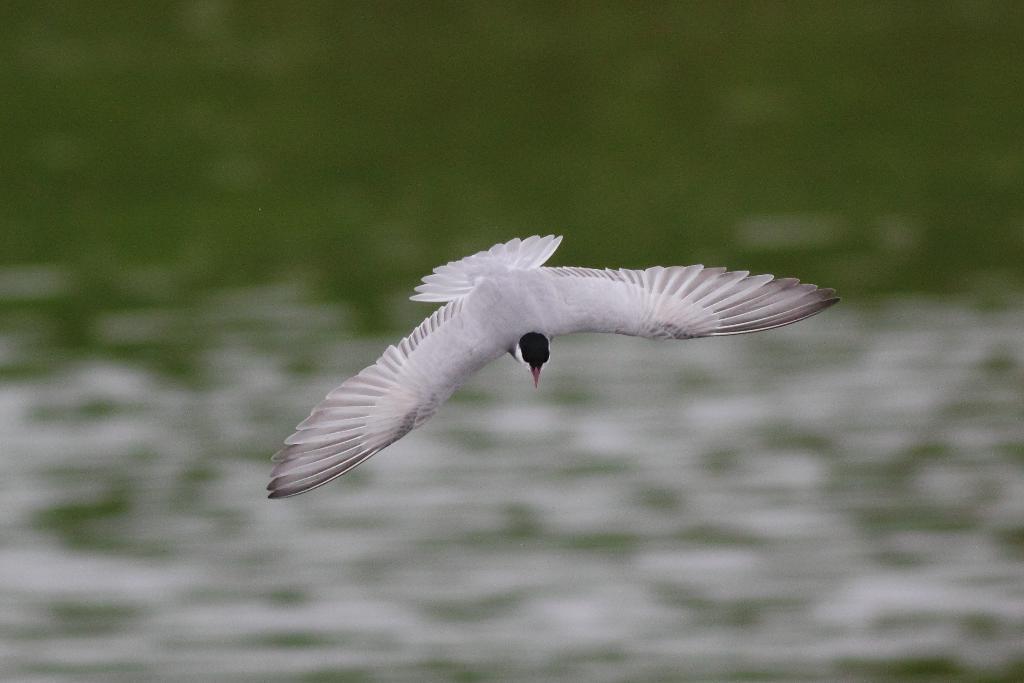Please provide a concise description of this image. This image consists of a bird flying. It is in white color. At the bottom, there is water. 